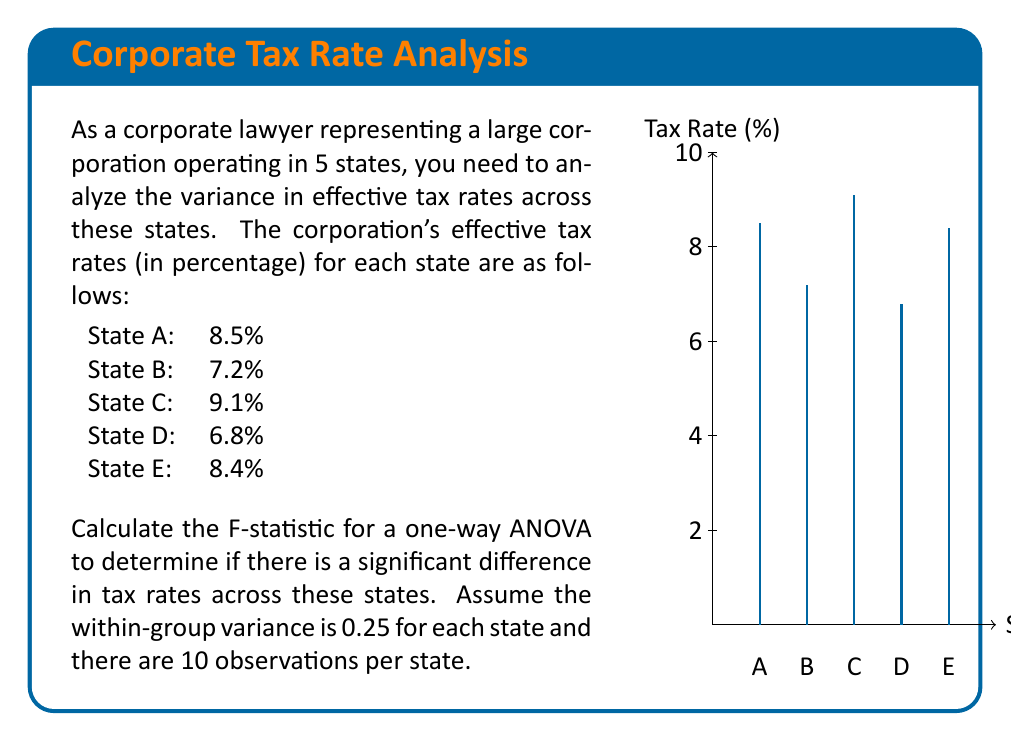Help me with this question. To calculate the F-statistic for a one-way ANOVA, we need to follow these steps:

1. Calculate the grand mean ($\bar{X}$):
   $$\bar{X} = \frac{8.5 + 7.2 + 9.1 + 6.8 + 8.4}{5} = 8$$

2. Calculate the between-group sum of squares (SSB):
   $$SSB = \sum_{i=1}^{k} n_i(\bar{X_i} - \bar{X})^2$$
   where $k$ is the number of groups (states), $n_i$ is the number of observations per group, and $\bar{X_i}$ is the mean of each group.
   
   $$SSB = 10[(8.5 - 8)^2 + (7.2 - 8)^2 + (9.1 - 8)^2 + (6.8 - 8)^2 + (8.4 - 8)^2]$$
   $$SSB = 10(0.25 + 0.64 + 1.21 + 1.44 + 0.16) = 37$$

3. Calculate the within-group sum of squares (SSW):
   $$SSW = \sum_{i=1}^{k} (n_i - 1)s_i^2$$
   where $s_i^2$ is the variance within each group.
   
   Given that the within-group variance is 0.25 for each state and there are 10 observations per state:
   $$SSW = 5 * (10 - 1) * 0.25 = 11.25$$

4. Calculate the degrees of freedom:
   Between-group df: $df_B = k - 1 = 5 - 1 = 4$
   Within-group df: $df_W = N - k = 50 - 5 = 45$, where $N$ is the total number of observations

5. Calculate the mean square between (MSB) and mean square within (MSW):
   $$MSB = \frac{SSB}{df_B} = \frac{37}{4} = 9.25$$
   $$MSW = \frac{SSW}{df_W} = \frac{11.25}{45} = 0.25$$

6. Calculate the F-statistic:
   $$F = \frac{MSB}{MSW} = \frac{9.25}{0.25} = 37$$
Answer: $F = 37$ 